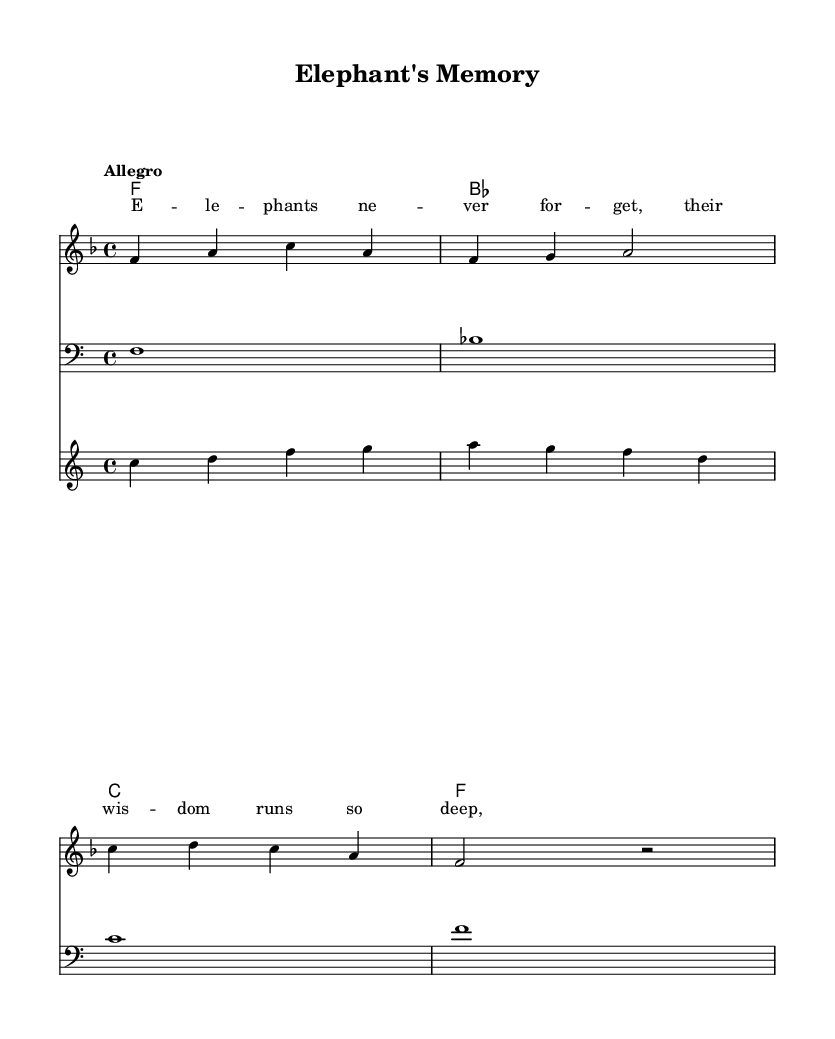What is the key signature of this music? The key signature indicates the key of F major, which has one flat (B flat). It is identified by examining the key indication next to the clef at the beginning of the music.
Answer: F major What is the time signature of this music? The time signature is displayed as 4/4, which means there are four beats in each measure and the quarter note receives one beat. This can be found at the beginning of the score, following the key signature.
Answer: 4/4 What is the tempo marking of this piece? The tempo marking is "Allegro," which indicates a fast and lively tempo. It can be seen at the beginning of the score under the tempo indication.
Answer: Allegro How many measures are in the melody section? The melody section consists of four measures as delineated by the vertical bar lines in the staff. Counting the measures between the bar lines provides the total.
Answer: 4 What is the last note of the bass line? The last note of the bass line is F. This is determined by looking at the last note in the bass staff, which matches the measures defined in the score.
Answer: F Which type of lyrics accompany the melody, and can you identify the theme? The lyrics are celebratory about elephants' wisdom, as seen in the opening line that states, "Elephants never forget, their wisdom runs so deep." Analyzing the lyrical content reveals the theme.
Answer: Wisdom 